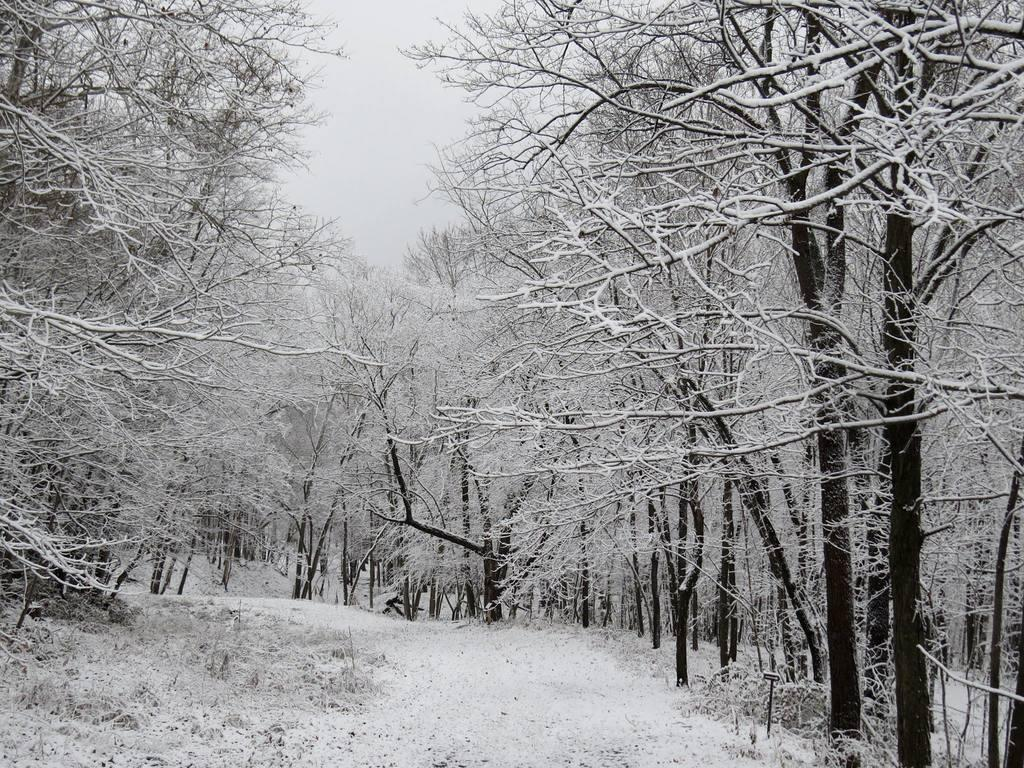What is located at the bottom of the image? There is a road at the bottom of the image. What can be seen on both sides of the road? There are trees on both sides of the road. What else can be seen in the background of the image? There are trees and clouds visible in the background of the image. What type of mouth can be seen on the trees in the image? There are no mouths present on the trees in the image. What is the trees writing on the road in the image? The trees are not writing anything on the road in the image. 